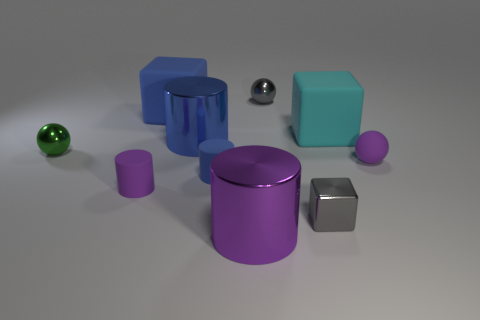How many objects are either small purple balls or small matte objects? In the image, there are a total of four small matte objects, including the small purple ball, small purple cylinder, small grey cube, and small teal cube. So the answer to the question is four objects. 